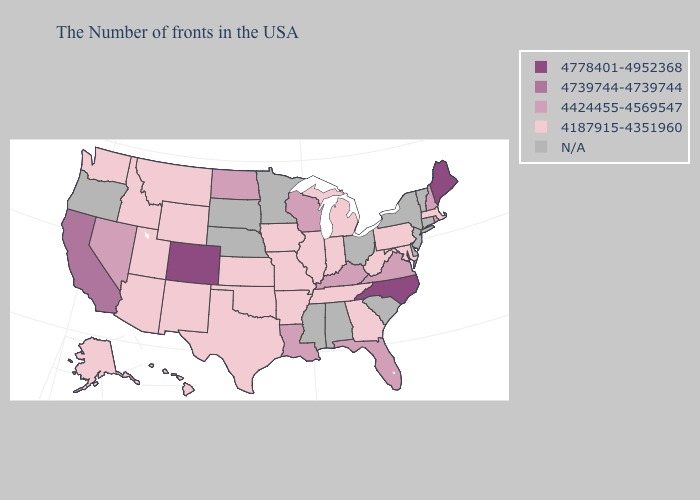Does Wisconsin have the lowest value in the MidWest?
Keep it brief. No. Does the first symbol in the legend represent the smallest category?
Quick response, please. No. Name the states that have a value in the range N/A?
Concise answer only. Vermont, Connecticut, New York, New Jersey, Delaware, South Carolina, Ohio, Alabama, Mississippi, Minnesota, Nebraska, South Dakota, Oregon. What is the highest value in the South ?
Short answer required. 4778401-4952368. Which states hav the highest value in the Northeast?
Concise answer only. Maine. What is the highest value in the USA?
Give a very brief answer. 4778401-4952368. Does Washington have the highest value in the West?
Give a very brief answer. No. What is the value of New York?
Concise answer only. N/A. Does Idaho have the highest value in the West?
Keep it brief. No. Among the states that border Maryland , does Virginia have the highest value?
Quick response, please. Yes. Among the states that border Utah , does Nevada have the highest value?
Write a very short answer. No. What is the value of Alabama?
Short answer required. N/A. 